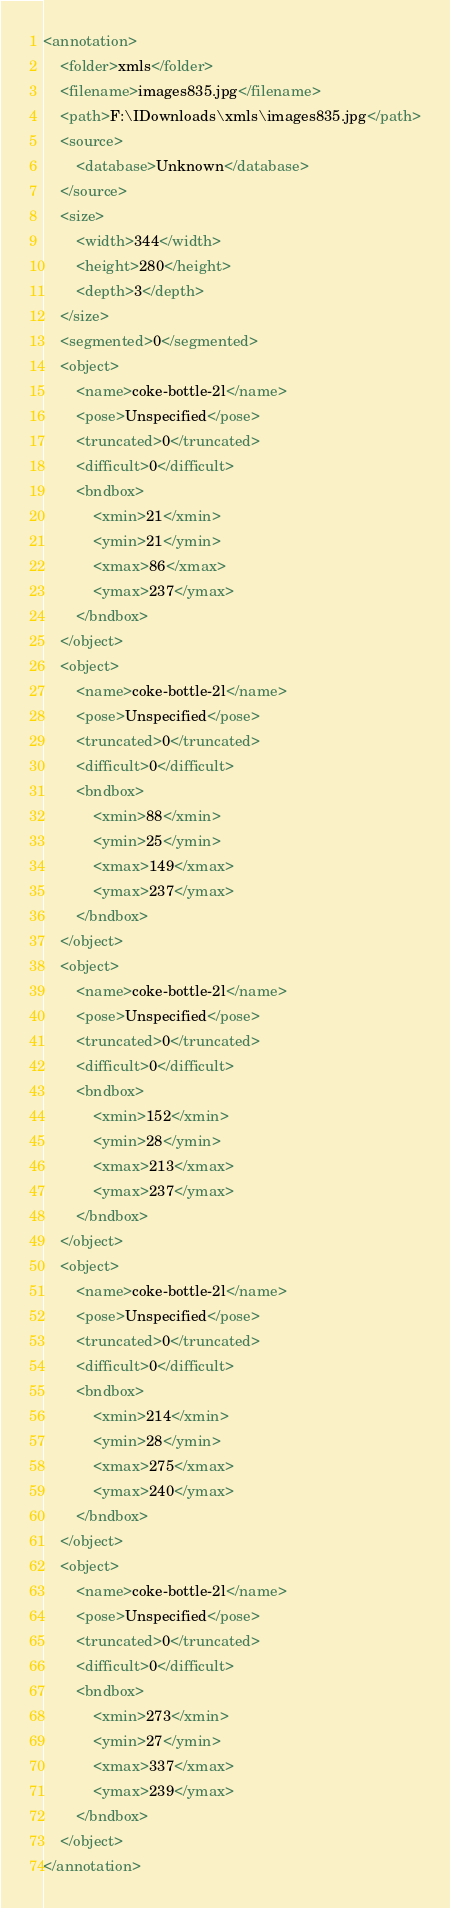<code> <loc_0><loc_0><loc_500><loc_500><_XML_><annotation>
	<folder>xmls</folder>
	<filename>images835.jpg</filename>
	<path>F:\IDownloads\xmls\images835.jpg</path>
	<source>
		<database>Unknown</database>
	</source>
	<size>
		<width>344</width>
		<height>280</height>
		<depth>3</depth>
	</size>
	<segmented>0</segmented>
	<object>
		<name>coke-bottle-2l</name>
		<pose>Unspecified</pose>
		<truncated>0</truncated>
		<difficult>0</difficult>
		<bndbox>
			<xmin>21</xmin>
			<ymin>21</ymin>
			<xmax>86</xmax>
			<ymax>237</ymax>
		</bndbox>
	</object>
	<object>
		<name>coke-bottle-2l</name>
		<pose>Unspecified</pose>
		<truncated>0</truncated>
		<difficult>0</difficult>
		<bndbox>
			<xmin>88</xmin>
			<ymin>25</ymin>
			<xmax>149</xmax>
			<ymax>237</ymax>
		</bndbox>
	</object>
	<object>
		<name>coke-bottle-2l</name>
		<pose>Unspecified</pose>
		<truncated>0</truncated>
		<difficult>0</difficult>
		<bndbox>
			<xmin>152</xmin>
			<ymin>28</ymin>
			<xmax>213</xmax>
			<ymax>237</ymax>
		</bndbox>
	</object>
	<object>
		<name>coke-bottle-2l</name>
		<pose>Unspecified</pose>
		<truncated>0</truncated>
		<difficult>0</difficult>
		<bndbox>
			<xmin>214</xmin>
			<ymin>28</ymin>
			<xmax>275</xmax>
			<ymax>240</ymax>
		</bndbox>
	</object>
	<object>
		<name>coke-bottle-2l</name>
		<pose>Unspecified</pose>
		<truncated>0</truncated>
		<difficult>0</difficult>
		<bndbox>
			<xmin>273</xmin>
			<ymin>27</ymin>
			<xmax>337</xmax>
			<ymax>239</ymax>
		</bndbox>
	</object>
</annotation>
</code> 